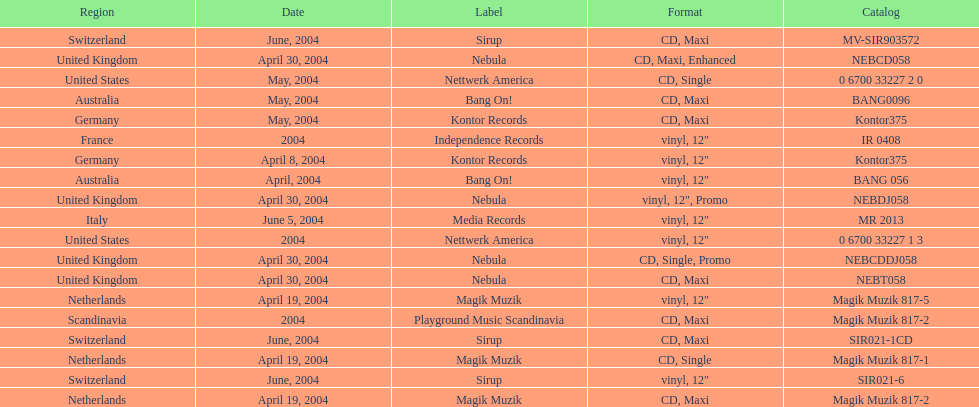What region is listed at the top? Netherlands. Give me the full table as a dictionary. {'header': ['Region', 'Date', 'Label', 'Format', 'Catalog'], 'rows': [['Switzerland', 'June, 2004', 'Sirup', 'CD, Maxi', 'MV-SIR903572'], ['United Kingdom', 'April 30, 2004', 'Nebula', 'CD, Maxi, Enhanced', 'NEBCD058'], ['United States', 'May, 2004', 'Nettwerk America', 'CD, Single', '0 6700 33227 2 0'], ['Australia', 'May, 2004', 'Bang On!', 'CD, Maxi', 'BANG0096'], ['Germany', 'May, 2004', 'Kontor Records', 'CD, Maxi', 'Kontor375'], ['France', '2004', 'Independence Records', 'vinyl, 12"', 'IR 0408'], ['Germany', 'April 8, 2004', 'Kontor Records', 'vinyl, 12"', 'Kontor375'], ['Australia', 'April, 2004', 'Bang On!', 'vinyl, 12"', 'BANG 056'], ['United Kingdom', 'April 30, 2004', 'Nebula', 'vinyl, 12", Promo', 'NEBDJ058'], ['Italy', 'June 5, 2004', 'Media Records', 'vinyl, 12"', 'MR 2013'], ['United States', '2004', 'Nettwerk America', 'vinyl, 12"', '0 6700 33227 1 3'], ['United Kingdom', 'April 30, 2004', 'Nebula', 'CD, Single, Promo', 'NEBCDDJ058'], ['United Kingdom', 'April 30, 2004', 'Nebula', 'CD, Maxi', 'NEBT058'], ['Netherlands', 'April 19, 2004', 'Magik Muzik', 'vinyl, 12"', 'Magik Muzik 817-5'], ['Scandinavia', '2004', 'Playground Music Scandinavia', 'CD, Maxi', 'Magik Muzik 817-2'], ['Switzerland', 'June, 2004', 'Sirup', 'CD, Maxi', 'SIR021-1CD'], ['Netherlands', 'April 19, 2004', 'Magik Muzik', 'CD, Single', 'Magik Muzik 817-1'], ['Switzerland', 'June, 2004', 'Sirup', 'vinyl, 12"', 'SIR021-6'], ['Netherlands', 'April 19, 2004', 'Magik Muzik', 'CD, Maxi', 'Magik Muzik 817-2']]} 